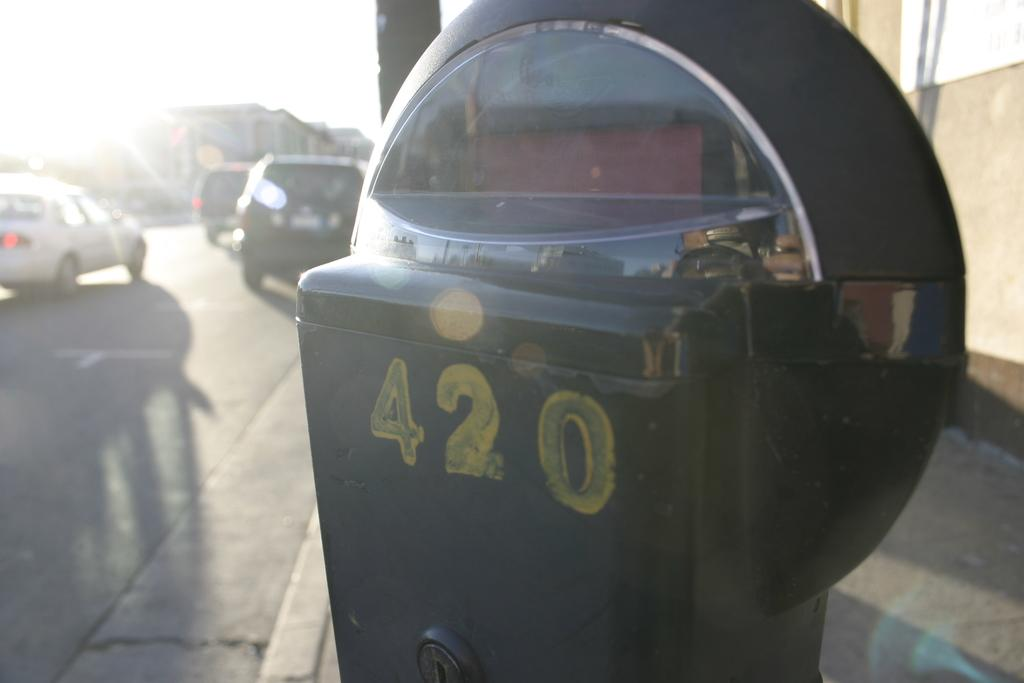Provide a one-sentence caption for the provided image. The number 420 is painted in yellow on a meter. 